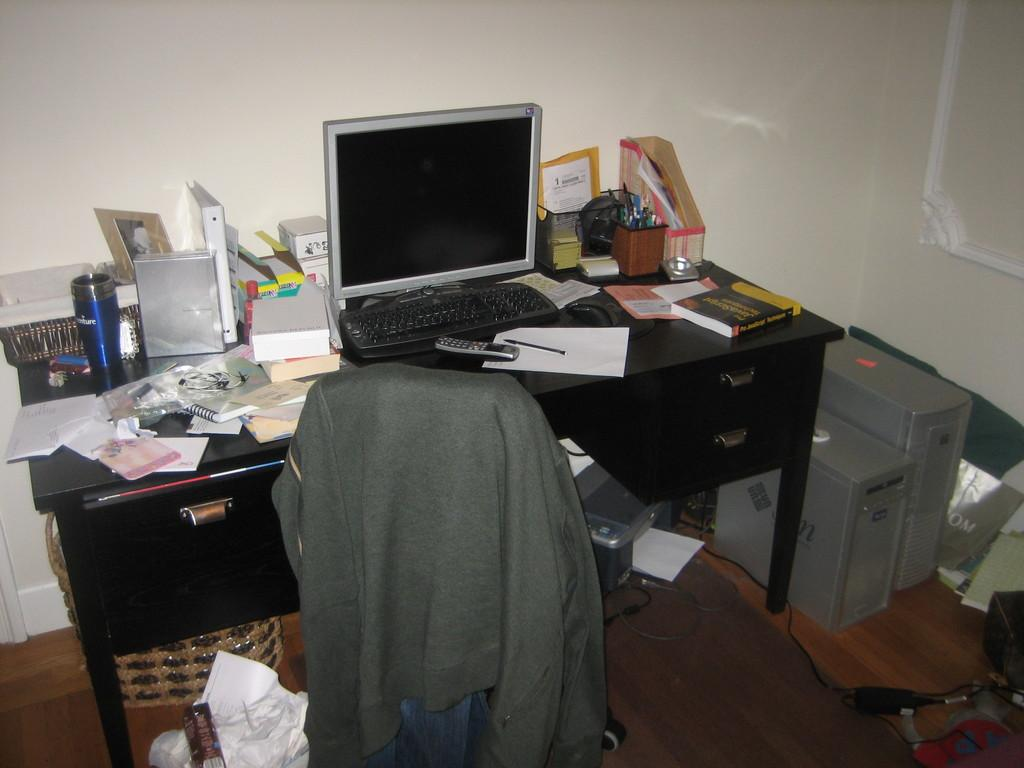What electronic device is visible in the image? There is a monitor in the image. What type of furniture is present in the image? There is a table in the image. What component of a computer system can be seen in the image? There is a CPU in the image. How many legs does the team have in the image? There is no team present in the image, so it is not possible to determine the number of legs. 